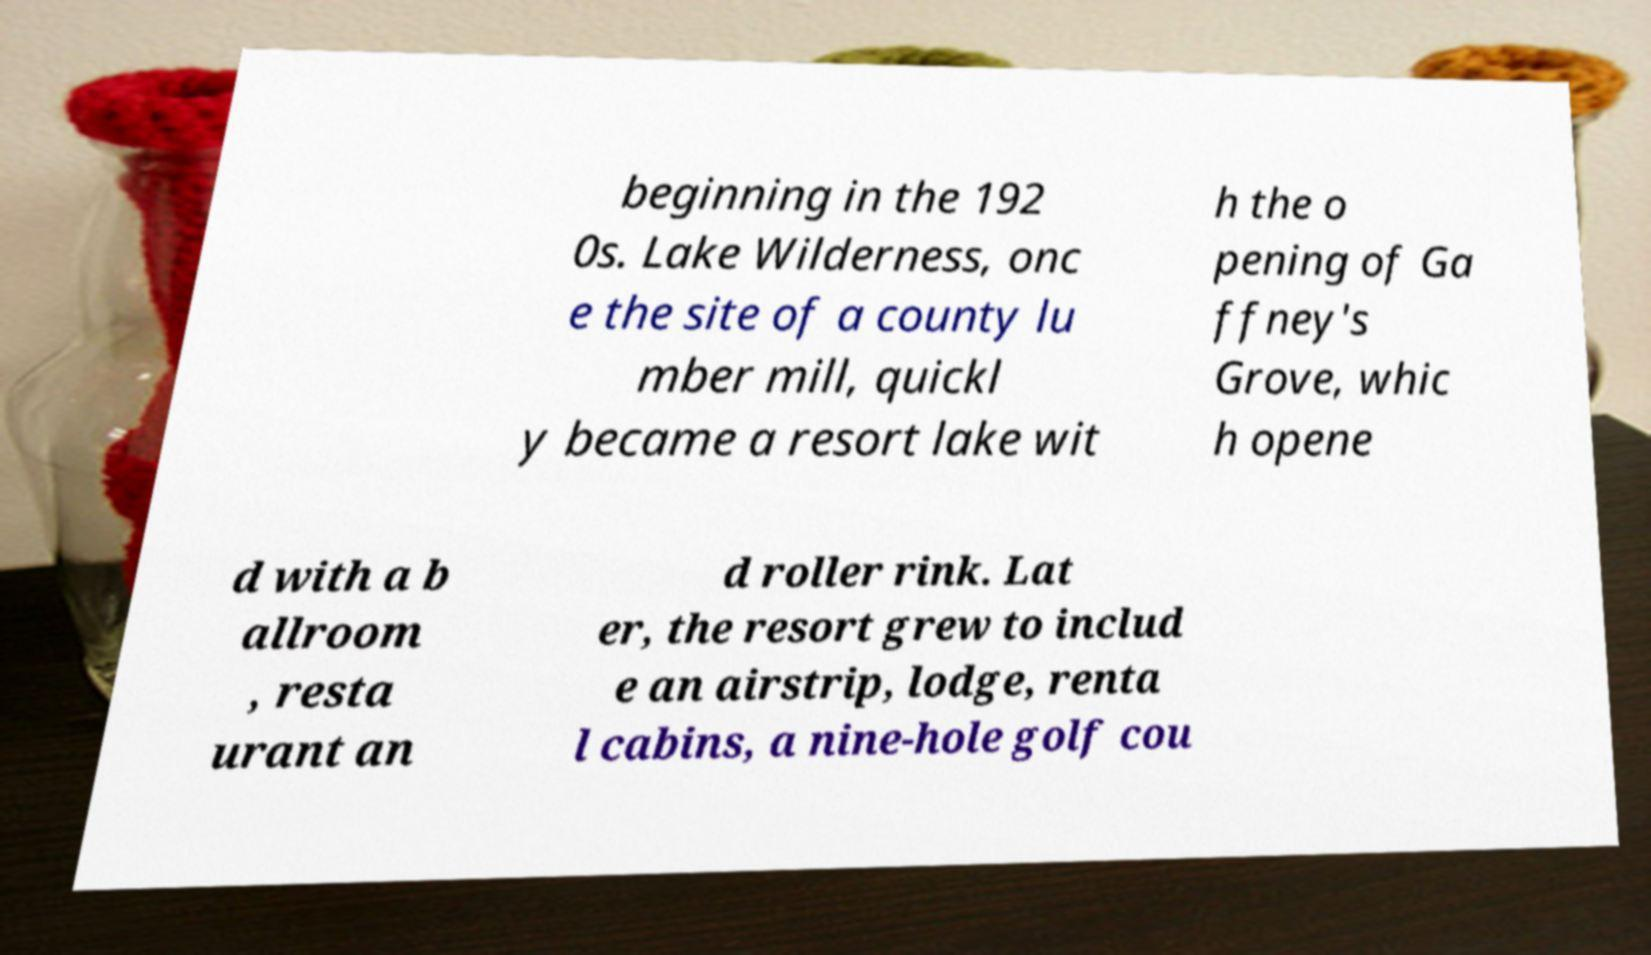Could you extract and type out the text from this image? beginning in the 192 0s. Lake Wilderness, onc e the site of a county lu mber mill, quickl y became a resort lake wit h the o pening of Ga ffney's Grove, whic h opene d with a b allroom , resta urant an d roller rink. Lat er, the resort grew to includ e an airstrip, lodge, renta l cabins, a nine-hole golf cou 